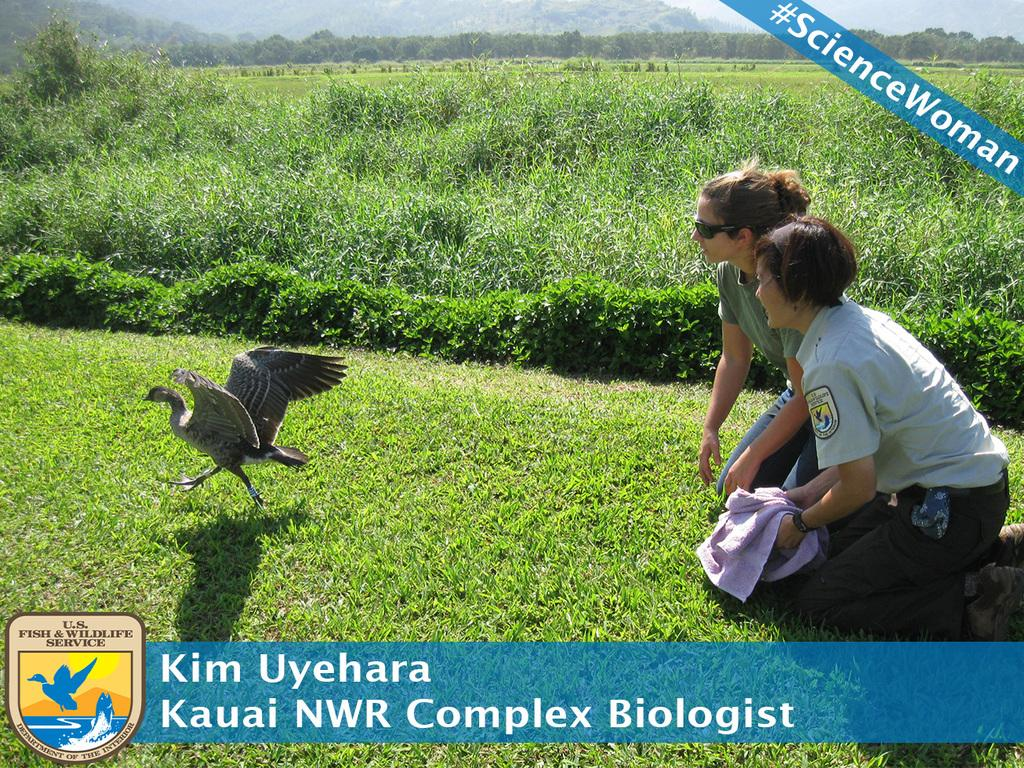How many people are in the image? There are people in the image, but the exact number is not specified. What type of animal can be seen in the image? There is a bird in the image. What type of vegetation is present in the image? There is grass, plants, and trees in the image. What type of natural landform is visible in the image? There are mountains in the image. What part of the natural environment is visible in the background of the image? The sky is visible in the background of the image. What type of thread is being used by the carpenter in the image? There is no carpenter or thread present in the image. How does the bubble affect the people in the image? There is no bubble present in the image. 